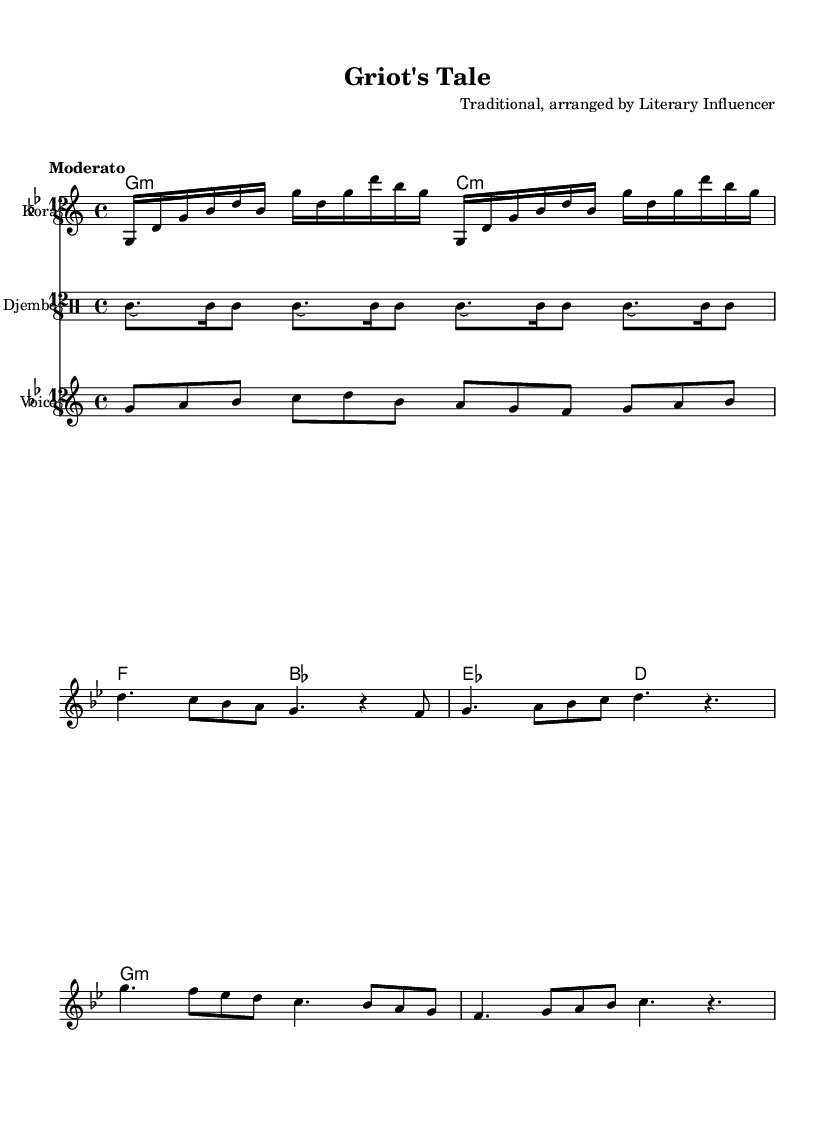What is the key signature of this music? The key signature is B flat minor, indicated by the two flats shown at the beginning of the staff.
Answer: B flat minor What is the time signature of this music? The time signature is 12/8, which is indicated at the beginning of the score, showing that there are twelve eighth notes per measure.
Answer: 12/8 What is the tempo marking for this piece? The tempo marking is "Moderato", which is given at the beginning of the score and indicates a moderate speed of performance.
Answer: Moderato How many measures are in the introductory section? The introductory section is made up of 8 measures, as counted from the notes and bar lines provided in the melody part.
Answer: 8 What are the main instruments used in this piece? The main instruments indicated in the score are the Kora and Djembe, explicitly written in their respective staff and drum staff, respectively.
Answer: Kora and Djembe What is the significance of storytelling in this type of music? Storytelling through music is significant because it serves to pass down history and cultural narratives, which is a traditional role of the Griot in African culture.
Answer: Cultural narrative How many chords are included in the harmonic progression? There are four distinct chords present in the harmonic progression shown in the chord mode section, which can be identified by the different chord symbols.
Answer: Four 